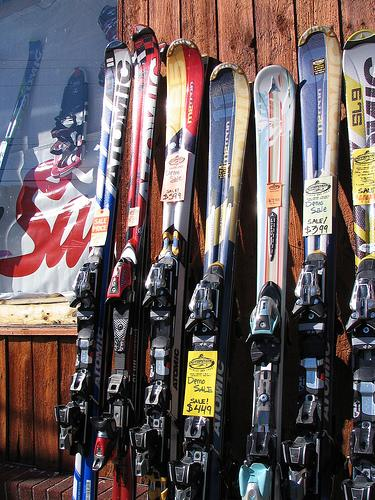Mention the colors and any text written on the Atomic skis. The Atomic skis are blue and white with the word "Atomic" written on them. Explain what can be seen in the display window. In the display window, there are snowshoes and skis for sale with different price tags. Count the number of skis in the image and describe their arrangement. There are seven skis lined up together, leaning against a wall. Describe any reflections that can be seen in the window. Utility lines can be seen reflected in the window. Identify the color and text found on the price tag attached to the skis. The price tag is yellow with black lettering, and it says "demo sale". Based on the image, are the skis for sale outside or inside the store? The skis are for sale outside of the store. What do the numbers "675" on the ski represent and what color are they? The numbers "675" likely represent a model number or identifier, and they are black. Provide a brief description of the price tag with "sale price" written on it. The price tag says "sale price" and it is small in size, with a width of 14 and a height of 14. What sentiment does this image evoke, considering the context and the details provided? The image evokes a feeling of excitement and anticipation for a skiing adventure with various skis and snowshoes on sale. What is the background behind the skis made of and describe its appearance? The background is made of wood and looks like a wooden wall of a ski store. What is written on the skis with a blue and white color scheme? Atomic. Which phrase is written on the price tag? Demo sale. What objects are displayed in the window of the ski shop? Skis and snowshoes. What is the number written on the ski and what color is it? 675, written in black on a yellow background. Can you find the green snowboard with number 19 written on it? The image only contains skis, not a snowboard, and there is no mention of any green objects or number 19 in the provided information. What is the background of the price tag on the ski? Yellow and black. What is the color of the brick at the bottom of the building? Red. Please notice the bike rack filled with mountain bikes beside the ski display. The image information does not mention any bikes or bike racks, it only focuses on skis and ski-related elements. In the corner, there is a large orange snowman wearing a purple hat. None of the described objects or captions in the image information mention any snowman or orange and purple elements. What is the color and pattern of the price tag on the skis? Yellow with black lettering. Find the dog that is sitting near the yellow price tag, wagging its tail. The image information does not mention any animals like dogs, so this object is nonexistent. Describe the arrangement of the skis in the image. The skis are propped up against a wooden wall, lined up together near a window. How many skis are depicted in the image and what are their general color schemes? There are seven skis, with color schemes like blue and white, red and white, and various other colors. Is there any lettering on the white and red price tag attached to the ski? Yes, it says "Sale Price." What is the color scheme of the ski with a pink light blue white and peach design? White and red. Describe the environment in which the skis are displayed. The skis are displayed inside the store, leaning against a wooden wall and visible through the ski shop's window. Observe the row of helmets hanging above the skis, can you identify which one is the largest? There is no mention of helmets or anything hanging above the skis in the image information, so this instruction is misleading. What is the main activity shown in the image? Selling skis and snowshoes. What is the main theme of the display window? Skis and snowshoes for sale. What type of shop is depicted in the image? A ski shop. Describe the scene shown in the image. There is a display window featuring skis and snowshoes available for sale, with the skis propped up against a wooden wall. Choose the correct description for the skis and their orientation: A) Skis in the air, B) Skis lying flat, C) Skis leaning against a wall. C) Skis leaning against a wall. Where is the man wearing a red jacket trying to pick up the pink ski? There is no mention of any person in the image information nor any pink ski, so this scenario does not exist in the image. What would you describe the scene shown in the image as? Skis for sale outside a store, propped up against a wall, and displayed in the store's window. 